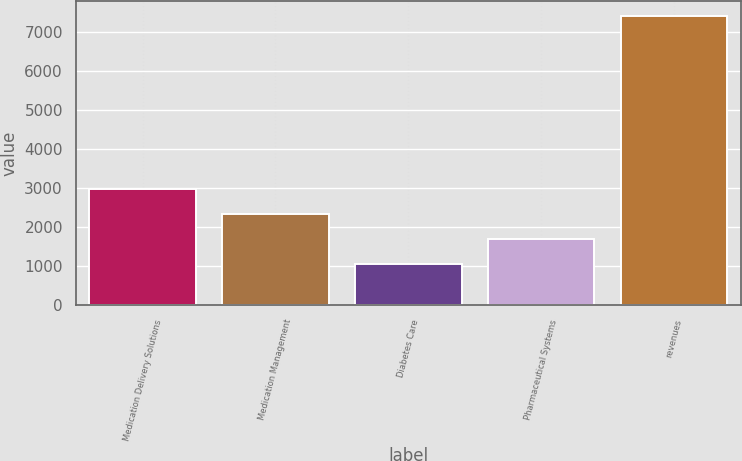<chart> <loc_0><loc_0><loc_500><loc_500><bar_chart><fcel>Medication Delivery Solutions<fcel>Medication Management<fcel>Diabetes Care<fcel>Pharmaceutical Systems<fcel>revenues<nl><fcel>2964.9<fcel>2328.6<fcel>1056<fcel>1692.3<fcel>7419<nl></chart> 